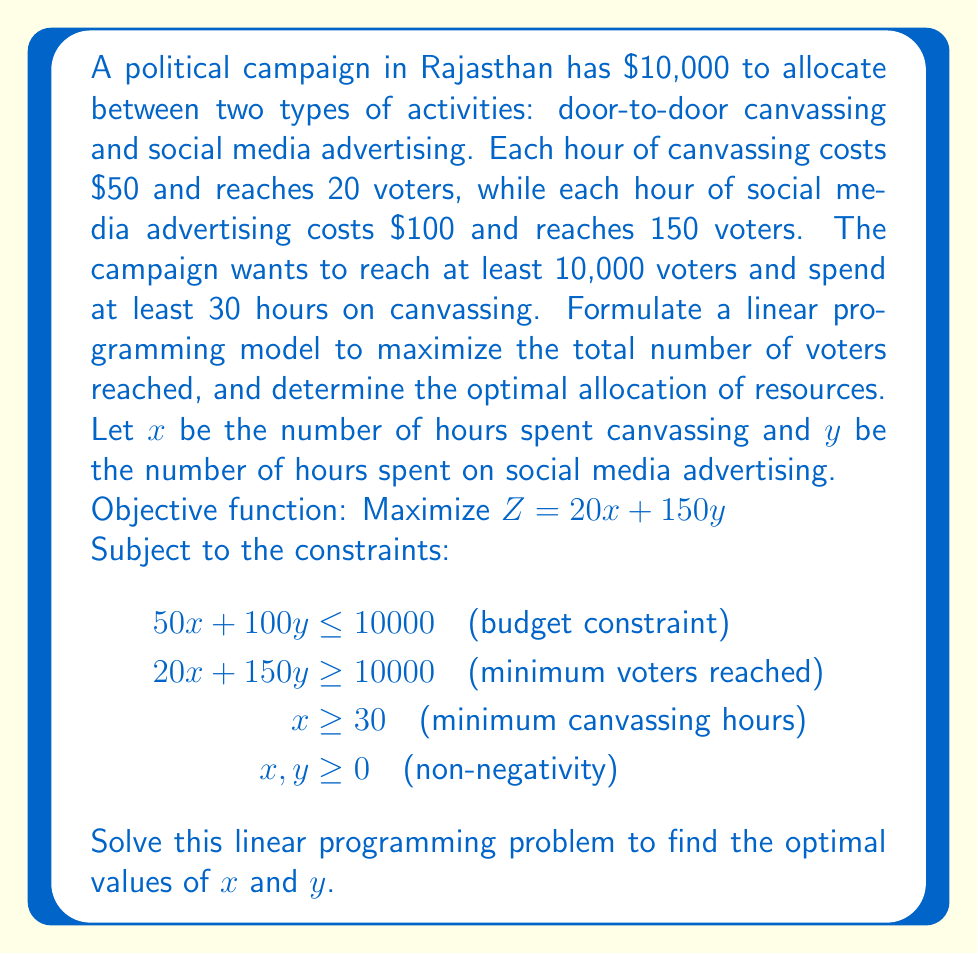Can you solve this math problem? To solve this linear programming problem, we'll use the graphical method:

1. Plot the constraints:
   a. Budget: $50x + 100y = 10000$ or $y = 100 - 0.5x$
   b. Minimum voters: $20x + 150y = 10000$ or $y = 66.67 - 0.133x$
   c. Minimum canvassing: $x = 30$

2. Identify the feasible region:
   The feasible region is the area that satisfies all constraints.

3. Find the corner points of the feasible region:
   A: (30, 85) - Intersection of $x = 30$ and budget line
   B: (100, 50) - Intersection of budget line and minimum voters line
   C: (200, 0) - Intersection of budget line and x-axis

4. Evaluate the objective function at each corner point:
   A: $Z = 20(30) + 150(85) = 13350$
   B: $Z = 20(100) + 150(50) = 9500$
   C: $Z = 20(200) + 150(0) = 4000$

5. The maximum value of Z occurs at point A (30, 85).

Therefore, the optimal solution is to spend 30 hours on canvassing and 85 hours on social media advertising, reaching a total of 13,350 voters.
Answer: 30 hours canvassing, 85 hours social media advertising; 13,350 voters reached 